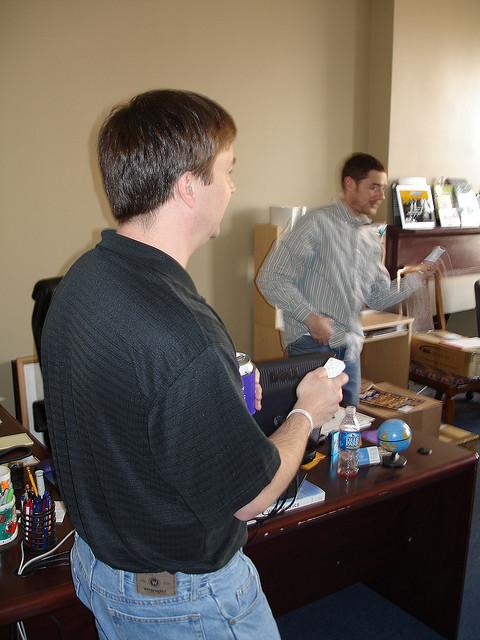What gaming system are the men playing?
Keep it brief. Wii. What color is the man's shirt?
Give a very brief answer. Black. How many people are playing?
Quick response, please. 2. 